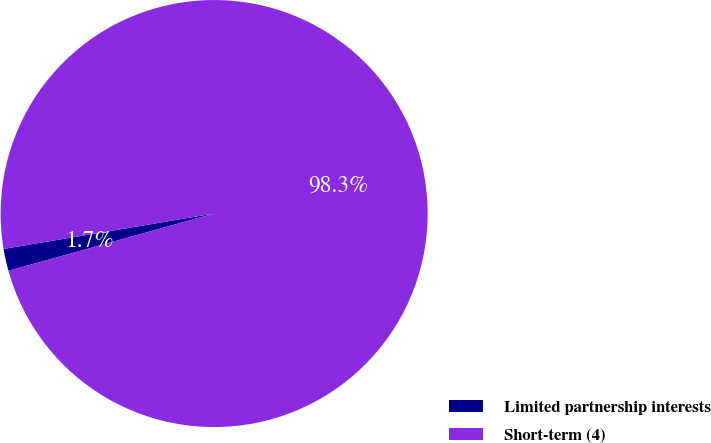Convert chart to OTSL. <chart><loc_0><loc_0><loc_500><loc_500><pie_chart><fcel>Limited partnership interests<fcel>Short-term (4)<nl><fcel>1.67%<fcel>98.33%<nl></chart> 